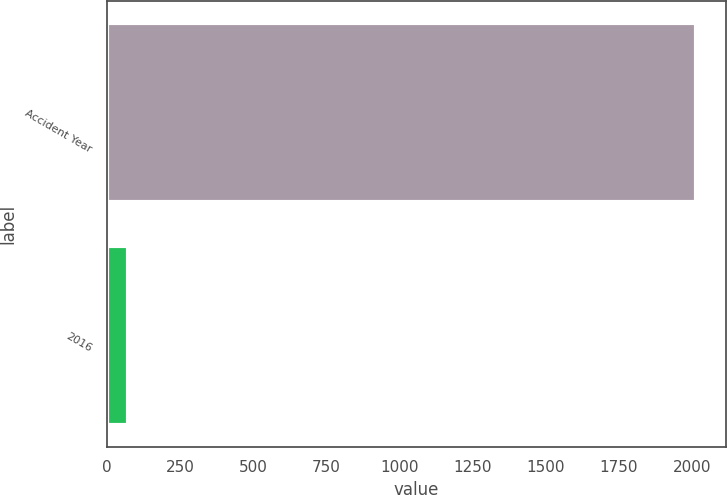Convert chart. <chart><loc_0><loc_0><loc_500><loc_500><bar_chart><fcel>Accident Year<fcel>2016<nl><fcel>2016<fcel>71<nl></chart> 